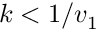Convert formula to latex. <formula><loc_0><loc_0><loc_500><loc_500>k < 1 / v _ { 1 }</formula> 